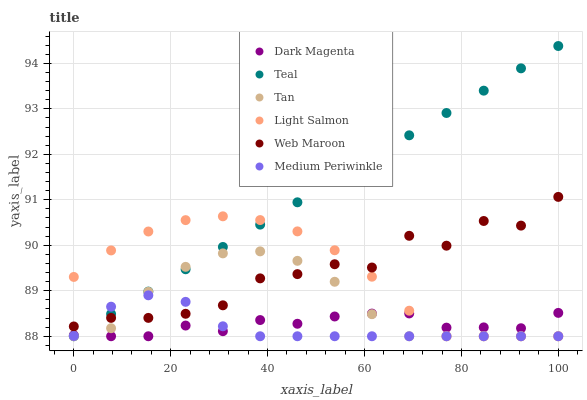Does Medium Periwinkle have the minimum area under the curve?
Answer yes or no. Yes. Does Teal have the maximum area under the curve?
Answer yes or no. Yes. Does Dark Magenta have the minimum area under the curve?
Answer yes or no. No. Does Dark Magenta have the maximum area under the curve?
Answer yes or no. No. Is Teal the smoothest?
Answer yes or no. Yes. Is Web Maroon the roughest?
Answer yes or no. Yes. Is Dark Magenta the smoothest?
Answer yes or no. No. Is Dark Magenta the roughest?
Answer yes or no. No. Does Light Salmon have the lowest value?
Answer yes or no. Yes. Does Web Maroon have the lowest value?
Answer yes or no. No. Does Teal have the highest value?
Answer yes or no. Yes. Does Web Maroon have the highest value?
Answer yes or no. No. Is Dark Magenta less than Web Maroon?
Answer yes or no. Yes. Is Web Maroon greater than Dark Magenta?
Answer yes or no. Yes. Does Tan intersect Medium Periwinkle?
Answer yes or no. Yes. Is Tan less than Medium Periwinkle?
Answer yes or no. No. Is Tan greater than Medium Periwinkle?
Answer yes or no. No. Does Dark Magenta intersect Web Maroon?
Answer yes or no. No. 